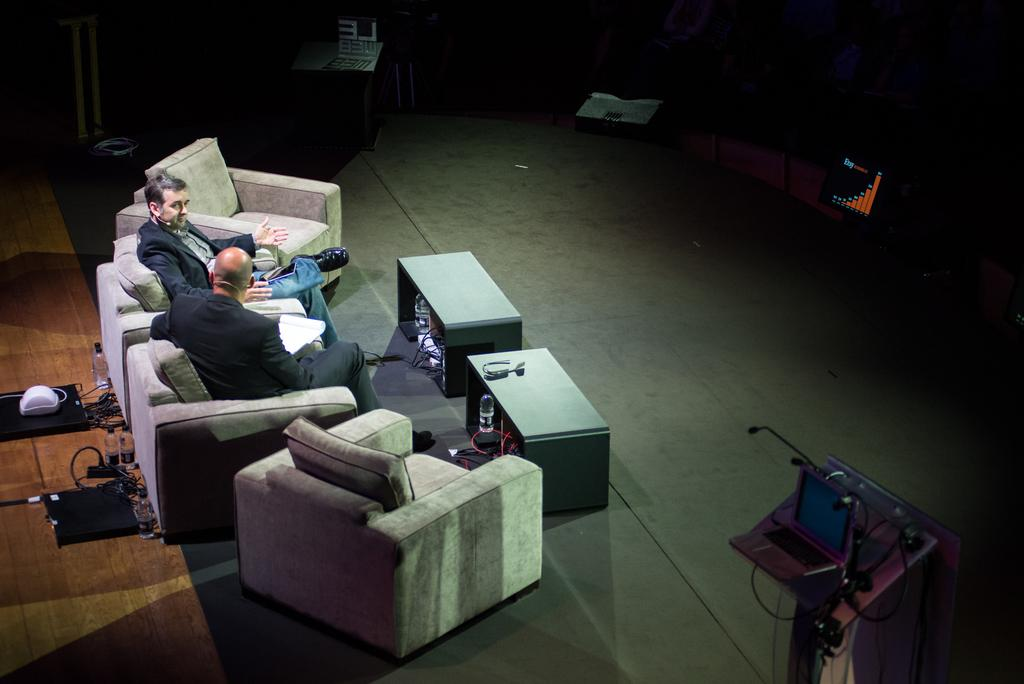How many people are sitting on the couch in the image? There are two people sitting on the couch in the image. What is the purpose of the podium in the image? The presence of a podium suggests that it might be used for presentations or speeches. What electronic device is visible in the image? There is a laptop in the image. What can be seen on the floor near the people sitting on the couch? There is a water bottle on the floor. What type of pet is sitting on the podium in the image? There is no pet present on the podium or anywhere else in the image. 